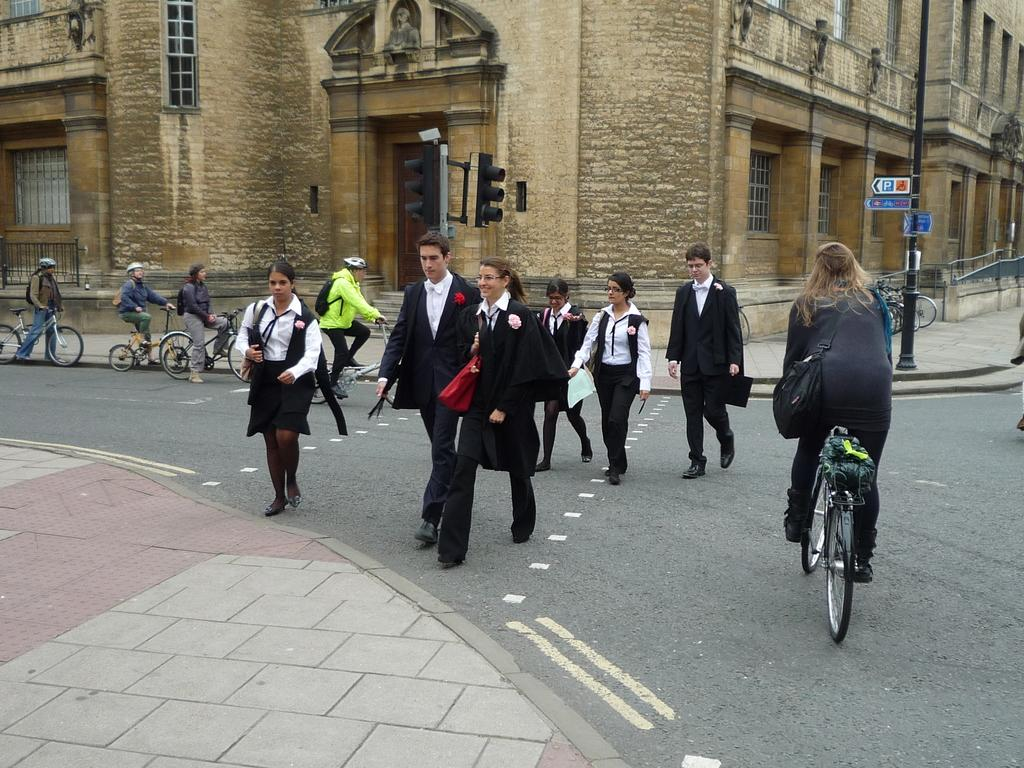How many people are in the image? There is a group of persons in the image. What are the persons in the image doing? The persons are crossing the road. Are any of the persons using a mode of transportation? Yes, some of the persons are riding bicycles. What can be seen in the background of the image? There is a building visible at the top of the image. What type of advice can be heard being given to the persons in the image? There is no indication in the image that any advice is being given to the persons. How many houses are visible in the image? There are no houses visible in the image; only a building can be seen in the background. 